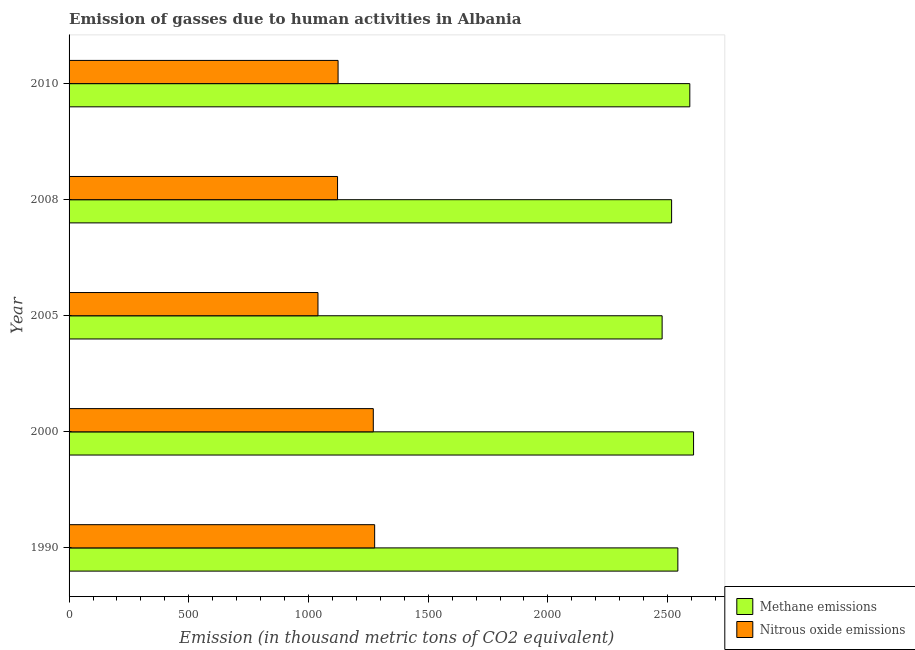How many bars are there on the 2nd tick from the bottom?
Your answer should be compact. 2. What is the label of the 4th group of bars from the top?
Give a very brief answer. 2000. In how many cases, is the number of bars for a given year not equal to the number of legend labels?
Ensure brevity in your answer.  0. What is the amount of methane emissions in 2000?
Provide a short and direct response. 2608.4. Across all years, what is the maximum amount of methane emissions?
Ensure brevity in your answer.  2608.4. Across all years, what is the minimum amount of nitrous oxide emissions?
Provide a short and direct response. 1039.6. In which year was the amount of nitrous oxide emissions maximum?
Ensure brevity in your answer.  1990. In which year was the amount of nitrous oxide emissions minimum?
Ensure brevity in your answer.  2005. What is the total amount of methane emissions in the graph?
Provide a succinct answer. 1.27e+04. What is the difference between the amount of nitrous oxide emissions in 2005 and that in 2010?
Offer a very short reply. -84. What is the difference between the amount of nitrous oxide emissions in 2008 and the amount of methane emissions in 1990?
Keep it short and to the point. -1421.4. What is the average amount of methane emissions per year?
Make the answer very short. 2547.54. In the year 2010, what is the difference between the amount of methane emissions and amount of nitrous oxide emissions?
Your answer should be compact. 1469.1. In how many years, is the amount of nitrous oxide emissions greater than 2300 thousand metric tons?
Provide a succinct answer. 0. What is the ratio of the amount of methane emissions in 2005 to that in 2010?
Your answer should be compact. 0.95. What is the difference between the highest and the second highest amount of nitrous oxide emissions?
Keep it short and to the point. 5.7. What is the difference between the highest and the lowest amount of nitrous oxide emissions?
Keep it short and to the point. 236.8. In how many years, is the amount of nitrous oxide emissions greater than the average amount of nitrous oxide emissions taken over all years?
Your answer should be compact. 2. Is the sum of the amount of methane emissions in 2005 and 2008 greater than the maximum amount of nitrous oxide emissions across all years?
Provide a short and direct response. Yes. What does the 1st bar from the top in 1990 represents?
Keep it short and to the point. Nitrous oxide emissions. What does the 1st bar from the bottom in 1990 represents?
Your answer should be very brief. Methane emissions. How many bars are there?
Keep it short and to the point. 10. Where does the legend appear in the graph?
Provide a short and direct response. Bottom right. What is the title of the graph?
Make the answer very short. Emission of gasses due to human activities in Albania. What is the label or title of the X-axis?
Ensure brevity in your answer.  Emission (in thousand metric tons of CO2 equivalent). What is the Emission (in thousand metric tons of CO2 equivalent) in Methane emissions in 1990?
Ensure brevity in your answer.  2542.8. What is the Emission (in thousand metric tons of CO2 equivalent) in Nitrous oxide emissions in 1990?
Your answer should be very brief. 1276.4. What is the Emission (in thousand metric tons of CO2 equivalent) in Methane emissions in 2000?
Provide a short and direct response. 2608.4. What is the Emission (in thousand metric tons of CO2 equivalent) in Nitrous oxide emissions in 2000?
Offer a very short reply. 1270.7. What is the Emission (in thousand metric tons of CO2 equivalent) of Methane emissions in 2005?
Make the answer very short. 2477.1. What is the Emission (in thousand metric tons of CO2 equivalent) of Nitrous oxide emissions in 2005?
Provide a succinct answer. 1039.6. What is the Emission (in thousand metric tons of CO2 equivalent) in Methane emissions in 2008?
Your response must be concise. 2516.7. What is the Emission (in thousand metric tons of CO2 equivalent) of Nitrous oxide emissions in 2008?
Offer a very short reply. 1121.4. What is the Emission (in thousand metric tons of CO2 equivalent) in Methane emissions in 2010?
Your answer should be compact. 2592.7. What is the Emission (in thousand metric tons of CO2 equivalent) in Nitrous oxide emissions in 2010?
Make the answer very short. 1123.6. Across all years, what is the maximum Emission (in thousand metric tons of CO2 equivalent) of Methane emissions?
Offer a terse response. 2608.4. Across all years, what is the maximum Emission (in thousand metric tons of CO2 equivalent) in Nitrous oxide emissions?
Your response must be concise. 1276.4. Across all years, what is the minimum Emission (in thousand metric tons of CO2 equivalent) in Methane emissions?
Provide a succinct answer. 2477.1. Across all years, what is the minimum Emission (in thousand metric tons of CO2 equivalent) in Nitrous oxide emissions?
Provide a short and direct response. 1039.6. What is the total Emission (in thousand metric tons of CO2 equivalent) in Methane emissions in the graph?
Your answer should be very brief. 1.27e+04. What is the total Emission (in thousand metric tons of CO2 equivalent) of Nitrous oxide emissions in the graph?
Your answer should be very brief. 5831.7. What is the difference between the Emission (in thousand metric tons of CO2 equivalent) of Methane emissions in 1990 and that in 2000?
Offer a terse response. -65.6. What is the difference between the Emission (in thousand metric tons of CO2 equivalent) of Methane emissions in 1990 and that in 2005?
Give a very brief answer. 65.7. What is the difference between the Emission (in thousand metric tons of CO2 equivalent) in Nitrous oxide emissions in 1990 and that in 2005?
Offer a very short reply. 236.8. What is the difference between the Emission (in thousand metric tons of CO2 equivalent) of Methane emissions in 1990 and that in 2008?
Offer a terse response. 26.1. What is the difference between the Emission (in thousand metric tons of CO2 equivalent) in Nitrous oxide emissions in 1990 and that in 2008?
Provide a short and direct response. 155. What is the difference between the Emission (in thousand metric tons of CO2 equivalent) in Methane emissions in 1990 and that in 2010?
Keep it short and to the point. -49.9. What is the difference between the Emission (in thousand metric tons of CO2 equivalent) of Nitrous oxide emissions in 1990 and that in 2010?
Your response must be concise. 152.8. What is the difference between the Emission (in thousand metric tons of CO2 equivalent) of Methane emissions in 2000 and that in 2005?
Your answer should be very brief. 131.3. What is the difference between the Emission (in thousand metric tons of CO2 equivalent) of Nitrous oxide emissions in 2000 and that in 2005?
Offer a very short reply. 231.1. What is the difference between the Emission (in thousand metric tons of CO2 equivalent) in Methane emissions in 2000 and that in 2008?
Ensure brevity in your answer.  91.7. What is the difference between the Emission (in thousand metric tons of CO2 equivalent) of Nitrous oxide emissions in 2000 and that in 2008?
Your response must be concise. 149.3. What is the difference between the Emission (in thousand metric tons of CO2 equivalent) of Methane emissions in 2000 and that in 2010?
Provide a short and direct response. 15.7. What is the difference between the Emission (in thousand metric tons of CO2 equivalent) of Nitrous oxide emissions in 2000 and that in 2010?
Give a very brief answer. 147.1. What is the difference between the Emission (in thousand metric tons of CO2 equivalent) of Methane emissions in 2005 and that in 2008?
Offer a terse response. -39.6. What is the difference between the Emission (in thousand metric tons of CO2 equivalent) in Nitrous oxide emissions in 2005 and that in 2008?
Offer a terse response. -81.8. What is the difference between the Emission (in thousand metric tons of CO2 equivalent) of Methane emissions in 2005 and that in 2010?
Your answer should be very brief. -115.6. What is the difference between the Emission (in thousand metric tons of CO2 equivalent) in Nitrous oxide emissions in 2005 and that in 2010?
Keep it short and to the point. -84. What is the difference between the Emission (in thousand metric tons of CO2 equivalent) of Methane emissions in 2008 and that in 2010?
Your answer should be very brief. -76. What is the difference between the Emission (in thousand metric tons of CO2 equivalent) of Methane emissions in 1990 and the Emission (in thousand metric tons of CO2 equivalent) of Nitrous oxide emissions in 2000?
Provide a succinct answer. 1272.1. What is the difference between the Emission (in thousand metric tons of CO2 equivalent) in Methane emissions in 1990 and the Emission (in thousand metric tons of CO2 equivalent) in Nitrous oxide emissions in 2005?
Provide a succinct answer. 1503.2. What is the difference between the Emission (in thousand metric tons of CO2 equivalent) of Methane emissions in 1990 and the Emission (in thousand metric tons of CO2 equivalent) of Nitrous oxide emissions in 2008?
Keep it short and to the point. 1421.4. What is the difference between the Emission (in thousand metric tons of CO2 equivalent) of Methane emissions in 1990 and the Emission (in thousand metric tons of CO2 equivalent) of Nitrous oxide emissions in 2010?
Offer a very short reply. 1419.2. What is the difference between the Emission (in thousand metric tons of CO2 equivalent) of Methane emissions in 2000 and the Emission (in thousand metric tons of CO2 equivalent) of Nitrous oxide emissions in 2005?
Your answer should be very brief. 1568.8. What is the difference between the Emission (in thousand metric tons of CO2 equivalent) in Methane emissions in 2000 and the Emission (in thousand metric tons of CO2 equivalent) in Nitrous oxide emissions in 2008?
Provide a short and direct response. 1487. What is the difference between the Emission (in thousand metric tons of CO2 equivalent) in Methane emissions in 2000 and the Emission (in thousand metric tons of CO2 equivalent) in Nitrous oxide emissions in 2010?
Keep it short and to the point. 1484.8. What is the difference between the Emission (in thousand metric tons of CO2 equivalent) of Methane emissions in 2005 and the Emission (in thousand metric tons of CO2 equivalent) of Nitrous oxide emissions in 2008?
Offer a very short reply. 1355.7. What is the difference between the Emission (in thousand metric tons of CO2 equivalent) of Methane emissions in 2005 and the Emission (in thousand metric tons of CO2 equivalent) of Nitrous oxide emissions in 2010?
Your response must be concise. 1353.5. What is the difference between the Emission (in thousand metric tons of CO2 equivalent) of Methane emissions in 2008 and the Emission (in thousand metric tons of CO2 equivalent) of Nitrous oxide emissions in 2010?
Offer a very short reply. 1393.1. What is the average Emission (in thousand metric tons of CO2 equivalent) of Methane emissions per year?
Offer a terse response. 2547.54. What is the average Emission (in thousand metric tons of CO2 equivalent) of Nitrous oxide emissions per year?
Your answer should be very brief. 1166.34. In the year 1990, what is the difference between the Emission (in thousand metric tons of CO2 equivalent) in Methane emissions and Emission (in thousand metric tons of CO2 equivalent) in Nitrous oxide emissions?
Your response must be concise. 1266.4. In the year 2000, what is the difference between the Emission (in thousand metric tons of CO2 equivalent) in Methane emissions and Emission (in thousand metric tons of CO2 equivalent) in Nitrous oxide emissions?
Provide a short and direct response. 1337.7. In the year 2005, what is the difference between the Emission (in thousand metric tons of CO2 equivalent) in Methane emissions and Emission (in thousand metric tons of CO2 equivalent) in Nitrous oxide emissions?
Provide a succinct answer. 1437.5. In the year 2008, what is the difference between the Emission (in thousand metric tons of CO2 equivalent) in Methane emissions and Emission (in thousand metric tons of CO2 equivalent) in Nitrous oxide emissions?
Your answer should be very brief. 1395.3. In the year 2010, what is the difference between the Emission (in thousand metric tons of CO2 equivalent) of Methane emissions and Emission (in thousand metric tons of CO2 equivalent) of Nitrous oxide emissions?
Provide a succinct answer. 1469.1. What is the ratio of the Emission (in thousand metric tons of CO2 equivalent) in Methane emissions in 1990 to that in 2000?
Offer a very short reply. 0.97. What is the ratio of the Emission (in thousand metric tons of CO2 equivalent) of Nitrous oxide emissions in 1990 to that in 2000?
Keep it short and to the point. 1. What is the ratio of the Emission (in thousand metric tons of CO2 equivalent) of Methane emissions in 1990 to that in 2005?
Keep it short and to the point. 1.03. What is the ratio of the Emission (in thousand metric tons of CO2 equivalent) in Nitrous oxide emissions in 1990 to that in 2005?
Your response must be concise. 1.23. What is the ratio of the Emission (in thousand metric tons of CO2 equivalent) of Methane emissions in 1990 to that in 2008?
Provide a succinct answer. 1.01. What is the ratio of the Emission (in thousand metric tons of CO2 equivalent) of Nitrous oxide emissions in 1990 to that in 2008?
Offer a terse response. 1.14. What is the ratio of the Emission (in thousand metric tons of CO2 equivalent) of Methane emissions in 1990 to that in 2010?
Your answer should be very brief. 0.98. What is the ratio of the Emission (in thousand metric tons of CO2 equivalent) of Nitrous oxide emissions in 1990 to that in 2010?
Make the answer very short. 1.14. What is the ratio of the Emission (in thousand metric tons of CO2 equivalent) of Methane emissions in 2000 to that in 2005?
Offer a terse response. 1.05. What is the ratio of the Emission (in thousand metric tons of CO2 equivalent) in Nitrous oxide emissions in 2000 to that in 2005?
Provide a succinct answer. 1.22. What is the ratio of the Emission (in thousand metric tons of CO2 equivalent) in Methane emissions in 2000 to that in 2008?
Keep it short and to the point. 1.04. What is the ratio of the Emission (in thousand metric tons of CO2 equivalent) in Nitrous oxide emissions in 2000 to that in 2008?
Your answer should be compact. 1.13. What is the ratio of the Emission (in thousand metric tons of CO2 equivalent) in Methane emissions in 2000 to that in 2010?
Your answer should be compact. 1.01. What is the ratio of the Emission (in thousand metric tons of CO2 equivalent) in Nitrous oxide emissions in 2000 to that in 2010?
Ensure brevity in your answer.  1.13. What is the ratio of the Emission (in thousand metric tons of CO2 equivalent) of Methane emissions in 2005 to that in 2008?
Provide a succinct answer. 0.98. What is the ratio of the Emission (in thousand metric tons of CO2 equivalent) of Nitrous oxide emissions in 2005 to that in 2008?
Make the answer very short. 0.93. What is the ratio of the Emission (in thousand metric tons of CO2 equivalent) of Methane emissions in 2005 to that in 2010?
Your answer should be very brief. 0.96. What is the ratio of the Emission (in thousand metric tons of CO2 equivalent) in Nitrous oxide emissions in 2005 to that in 2010?
Your answer should be compact. 0.93. What is the ratio of the Emission (in thousand metric tons of CO2 equivalent) in Methane emissions in 2008 to that in 2010?
Ensure brevity in your answer.  0.97. What is the difference between the highest and the second highest Emission (in thousand metric tons of CO2 equivalent) in Methane emissions?
Make the answer very short. 15.7. What is the difference between the highest and the second highest Emission (in thousand metric tons of CO2 equivalent) in Nitrous oxide emissions?
Offer a very short reply. 5.7. What is the difference between the highest and the lowest Emission (in thousand metric tons of CO2 equivalent) in Methane emissions?
Your response must be concise. 131.3. What is the difference between the highest and the lowest Emission (in thousand metric tons of CO2 equivalent) in Nitrous oxide emissions?
Give a very brief answer. 236.8. 